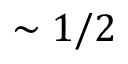<formula> <loc_0><loc_0><loc_500><loc_500>\sim 1 / 2</formula> 